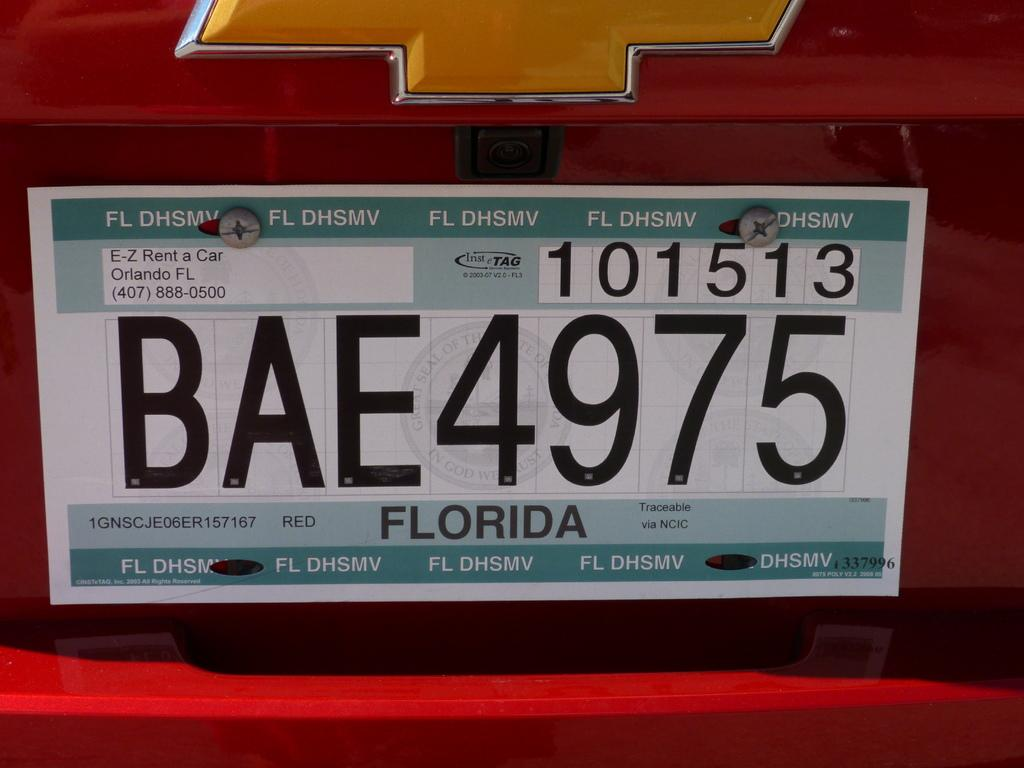<image>
Describe the image concisely. a Florida license plate with many digits on it 